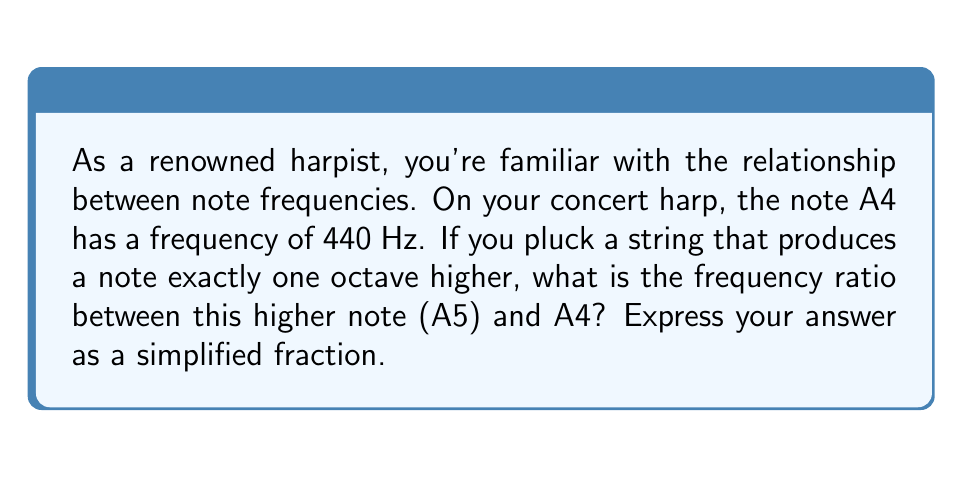Show me your answer to this math problem. To solve this problem, we need to understand the relationship between octaves and frequencies in music theory:

1) An octave is an interval between two musical notes where one has twice the frequency of the other.

2) The frequency ratio between two notes an octave apart is always 2:1.

3) In this case, A5 is one octave higher than A4.

Let's define our variables:
$f_1$ = frequency of A4 = 440 Hz
$f_2$ = frequency of A5

We know that $f_2$ is one octave higher than $f_1$, so:

$$f_2 = 2f_1$$

The frequency ratio is defined as:

$$\text{Frequency Ratio} = \frac{f_2}{f_1}$$

Substituting what we know:

$$\text{Frequency Ratio} = \frac{2f_1}{f_1}$$

This simplifies to:

$$\text{Frequency Ratio} = \frac{2}{1} = 2$$

Therefore, the frequency ratio between A5 and A4 is 2:1 or simply 2.
Answer: $2:1$ or $2$ 